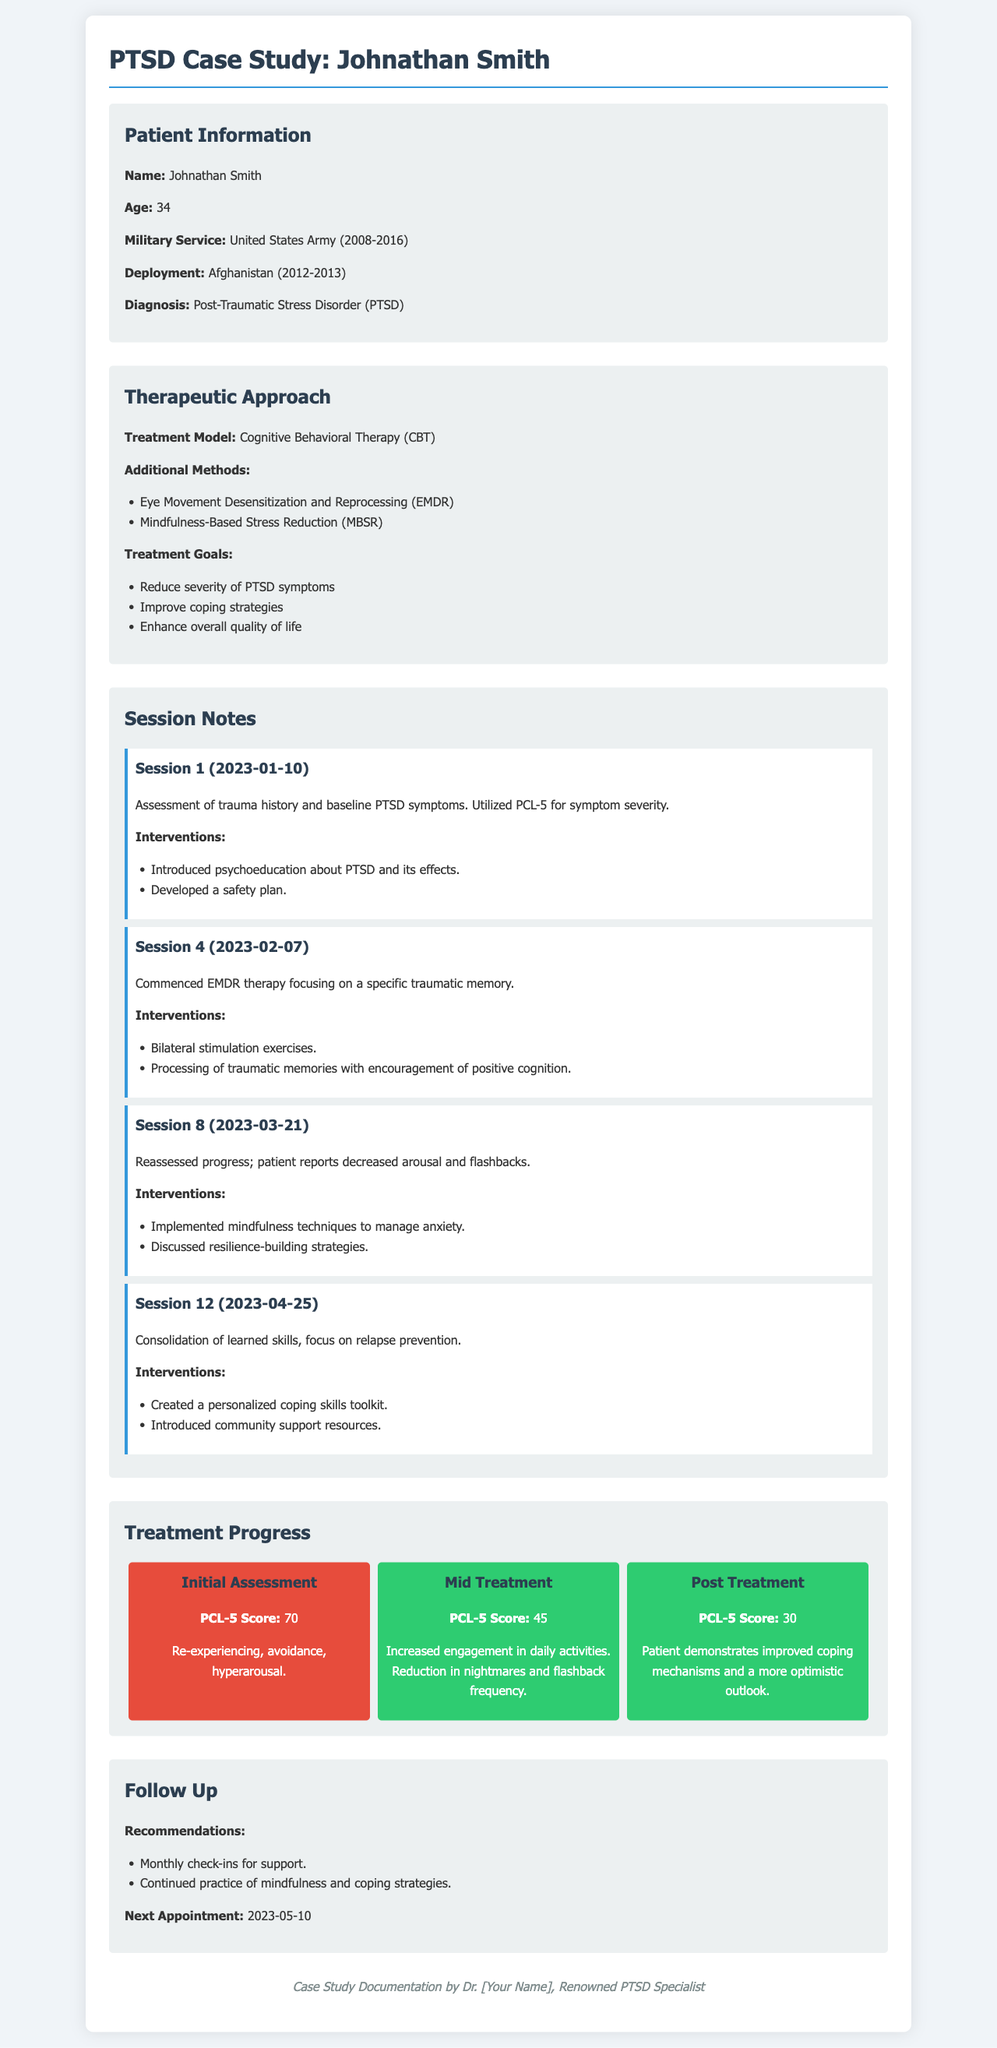What is the patient's name? The patient's name is mentioned in the Patient Information section of the document.
Answer: Johnathan Smith What is the patient's age? The age of the patient is specified in the Patient Information section.
Answer: 34 What therapy model is primarily used? The primary treatment model is stated in the Therapeutic Approach section.
Answer: Cognitive Behavioral Therapy (CBT) When did the first session occur? The date of the first session can be found in the Session Notes section.
Answer: 2023-01-10 What was the PCL-5 score at the initial assessment? The initial assessment score is reported under the Treatment Progress section.
Answer: 70 Which method was introduced in Session 4? The intervention used in Session 4 is listed in the Session Notes section.
Answer: EMDR therapy What is recommended for follow-up care? Recommendations for follow-up care are outlined in the Follow Up section.
Answer: Monthly check-ins What improvements were reported by the patient in mid-treatment? The specific improvements from the Treatment Progress section reflect the patient's progress.
Answer: Reduction in nightmares and flashback frequency What tools were created in Session 12? The interventions outlined in Session 12 detail the specific tools discussed.
Answer: Personalized coping skills toolkit 